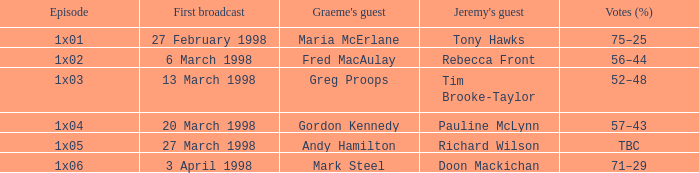What is Episode, when Jeremy's Guest is "Pauline McLynn"? 1x04. 